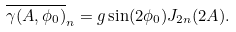Convert formula to latex. <formula><loc_0><loc_0><loc_500><loc_500>\overline { \gamma ( A , \phi _ { 0 } ) } _ { n } = g \sin ( 2 \phi _ { 0 } ) J _ { 2 n } ( 2 A ) .</formula> 